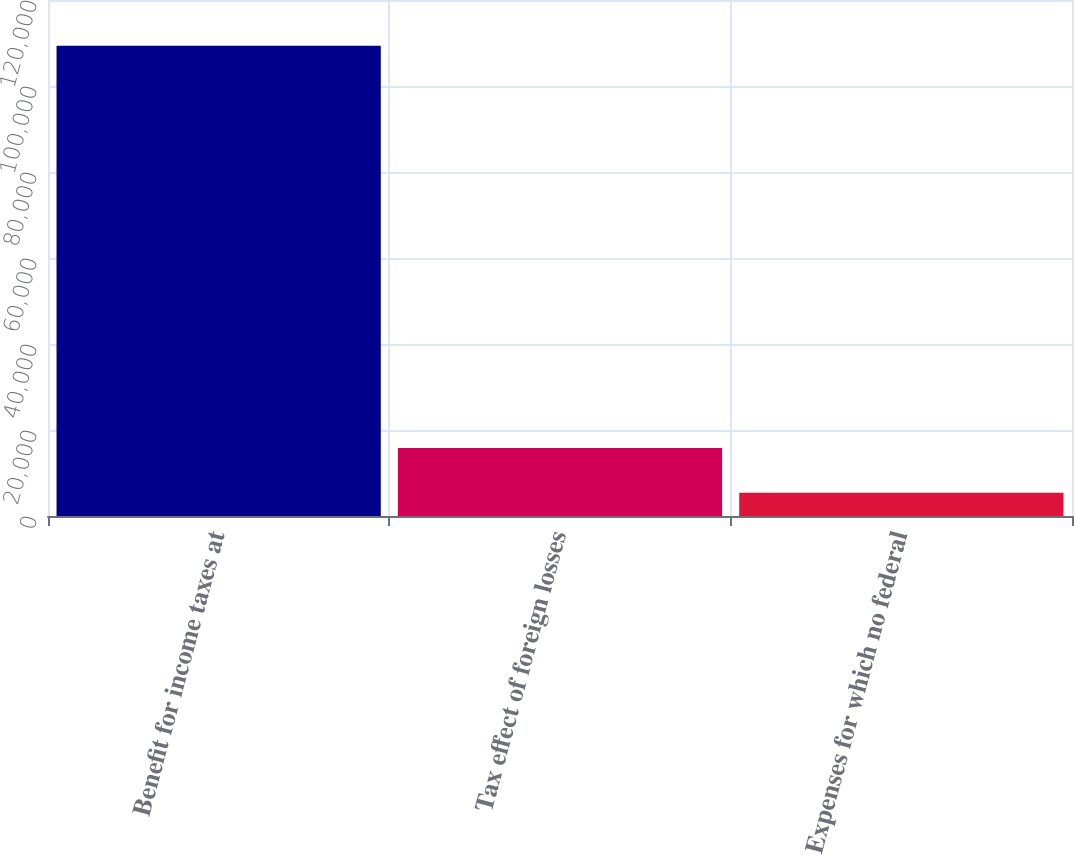<chart> <loc_0><loc_0><loc_500><loc_500><bar_chart><fcel>Benefit for income taxes at<fcel>Tax effect of foreign losses<fcel>Expenses for which no federal<nl><fcel>109364<fcel>15791<fcel>5394<nl></chart> 